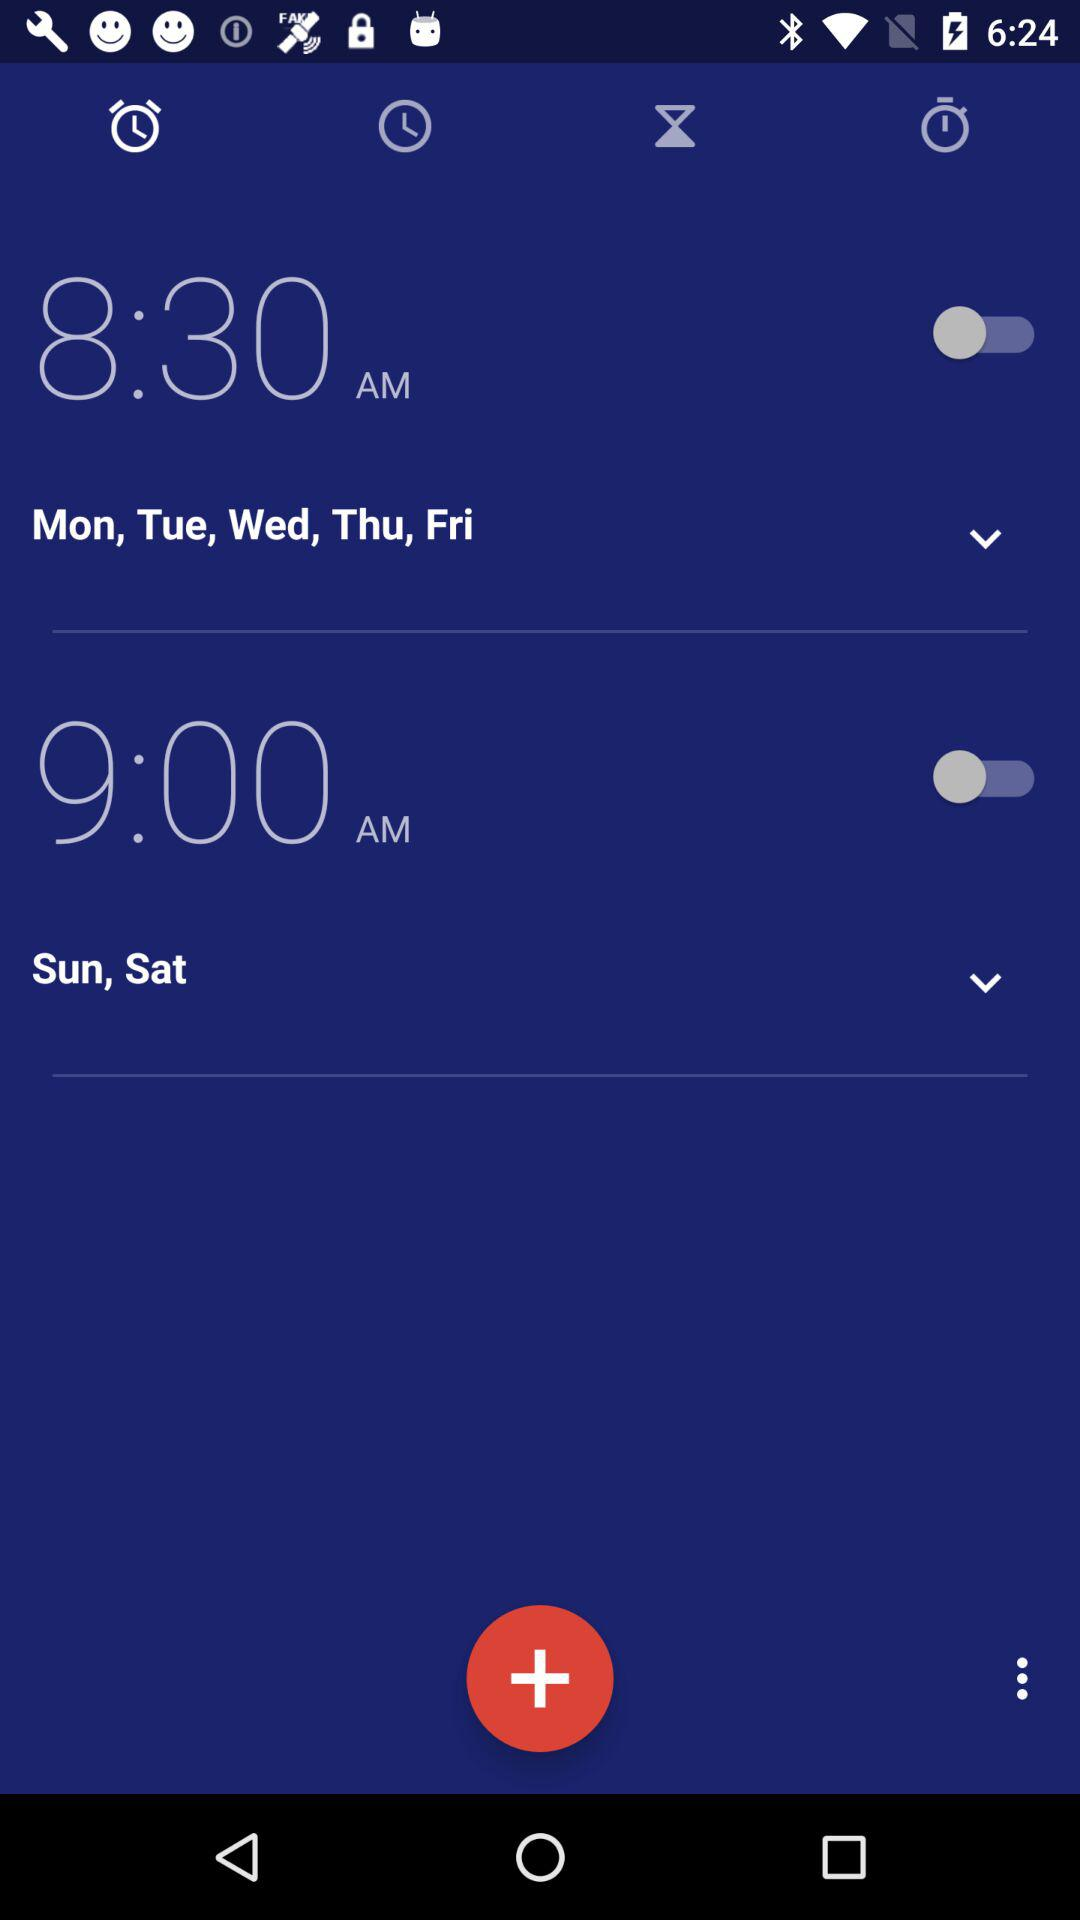For which days is the alarm set for 8:30 a.m.? The alarm is set for Monday, Tuesday, Wednesday, Thursday and Friday. 